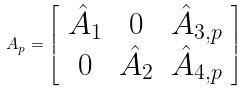<formula> <loc_0><loc_0><loc_500><loc_500>A _ { p } = \left [ \begin{array} { c c c } \hat { A } _ { 1 } & 0 & \hat { A } _ { 3 , p } \\ 0 & \hat { A } _ { 2 } & \hat { A } _ { 4 , p } \end{array} \right ]</formula> 